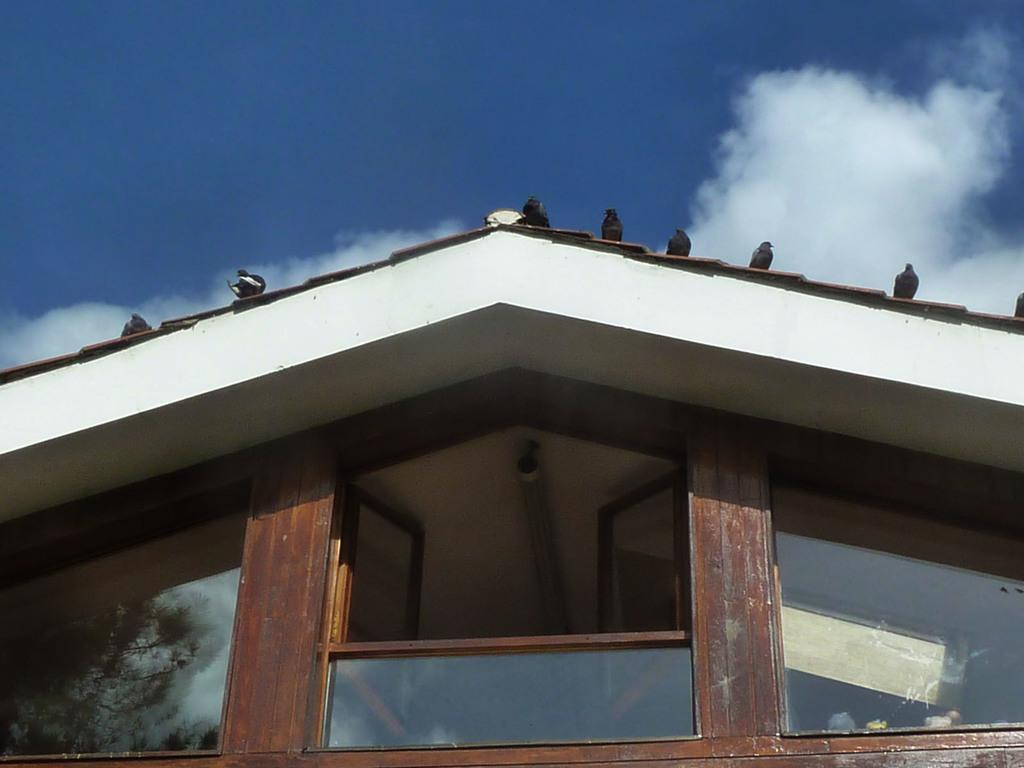What is the main subject in the center of the image? There is a house in the center of the image. Are there any animals present on the house? Yes, there are pigeons on the house. What can be seen at the top of the image? The sky is visible at the top of the image. What type of pet can be seen playing with a pipe in the image? There is no pet or pipe present in the image; it features a house with pigeons on it. Can you tell me how many cables are connected to the house in the image? There is no information about cables connected to the house in the image; it only shows a house with pigeons on it and the sky visible at the top. 